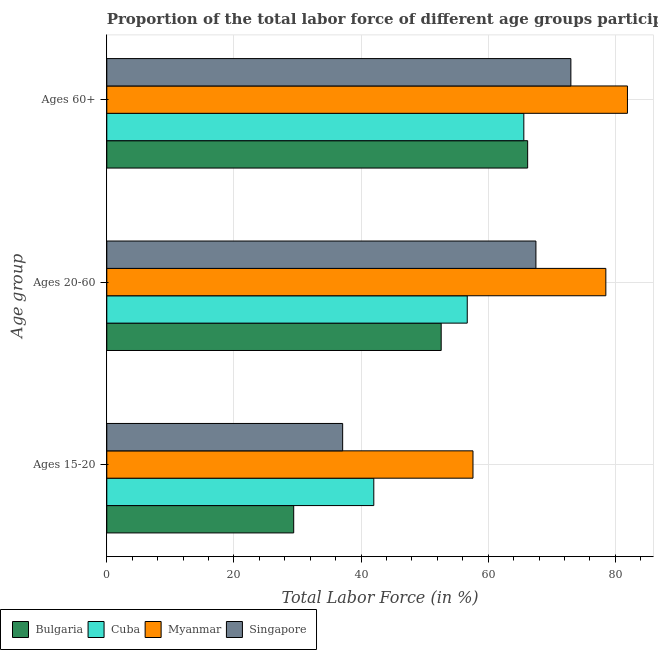Are the number of bars per tick equal to the number of legend labels?
Make the answer very short. Yes. Are the number of bars on each tick of the Y-axis equal?
Offer a terse response. Yes. How many bars are there on the 2nd tick from the bottom?
Provide a short and direct response. 4. What is the label of the 3rd group of bars from the top?
Keep it short and to the point. Ages 15-20. What is the percentage of labor force within the age group 20-60 in Singapore?
Offer a very short reply. 67.5. Across all countries, what is the maximum percentage of labor force within the age group 20-60?
Provide a short and direct response. 78.5. Across all countries, what is the minimum percentage of labor force within the age group 20-60?
Your response must be concise. 52.6. In which country was the percentage of labor force above age 60 maximum?
Your response must be concise. Myanmar. What is the total percentage of labor force within the age group 20-60 in the graph?
Keep it short and to the point. 255.3. What is the difference between the percentage of labor force above age 60 in Bulgaria and that in Singapore?
Offer a terse response. -6.8. What is the difference between the percentage of labor force within the age group 20-60 in Cuba and the percentage of labor force above age 60 in Bulgaria?
Keep it short and to the point. -9.5. What is the average percentage of labor force within the age group 20-60 per country?
Your response must be concise. 63.82. What is the difference between the percentage of labor force above age 60 and percentage of labor force within the age group 15-20 in Bulgaria?
Your answer should be compact. 36.8. In how many countries, is the percentage of labor force within the age group 20-60 greater than 52 %?
Provide a succinct answer. 4. What is the ratio of the percentage of labor force above age 60 in Cuba to that in Singapore?
Ensure brevity in your answer.  0.9. Is the percentage of labor force within the age group 20-60 in Myanmar less than that in Singapore?
Provide a short and direct response. No. What is the difference between the highest and the second highest percentage of labor force within the age group 15-20?
Keep it short and to the point. 15.6. What is the difference between the highest and the lowest percentage of labor force within the age group 15-20?
Keep it short and to the point. 28.2. In how many countries, is the percentage of labor force within the age group 15-20 greater than the average percentage of labor force within the age group 15-20 taken over all countries?
Offer a very short reply. 2. What does the 3rd bar from the top in Ages 20-60 represents?
Ensure brevity in your answer.  Cuba. How many bars are there?
Offer a terse response. 12. Are all the bars in the graph horizontal?
Your answer should be very brief. Yes. What is the difference between two consecutive major ticks on the X-axis?
Keep it short and to the point. 20. Are the values on the major ticks of X-axis written in scientific E-notation?
Your answer should be very brief. No. Does the graph contain any zero values?
Your answer should be compact. No. How are the legend labels stacked?
Provide a short and direct response. Horizontal. What is the title of the graph?
Offer a very short reply. Proportion of the total labor force of different age groups participating in production in 2011. What is the label or title of the Y-axis?
Ensure brevity in your answer.  Age group. What is the Total Labor Force (in %) in Bulgaria in Ages 15-20?
Provide a short and direct response. 29.4. What is the Total Labor Force (in %) in Myanmar in Ages 15-20?
Ensure brevity in your answer.  57.6. What is the Total Labor Force (in %) in Singapore in Ages 15-20?
Your answer should be compact. 37.1. What is the Total Labor Force (in %) in Bulgaria in Ages 20-60?
Your answer should be compact. 52.6. What is the Total Labor Force (in %) in Cuba in Ages 20-60?
Offer a terse response. 56.7. What is the Total Labor Force (in %) of Myanmar in Ages 20-60?
Your answer should be compact. 78.5. What is the Total Labor Force (in %) in Singapore in Ages 20-60?
Offer a terse response. 67.5. What is the Total Labor Force (in %) in Bulgaria in Ages 60+?
Your answer should be very brief. 66.2. What is the Total Labor Force (in %) in Cuba in Ages 60+?
Provide a short and direct response. 65.6. What is the Total Labor Force (in %) in Myanmar in Ages 60+?
Ensure brevity in your answer.  81.9. What is the Total Labor Force (in %) in Singapore in Ages 60+?
Provide a succinct answer. 73. Across all Age group, what is the maximum Total Labor Force (in %) in Bulgaria?
Ensure brevity in your answer.  66.2. Across all Age group, what is the maximum Total Labor Force (in %) in Cuba?
Your answer should be very brief. 65.6. Across all Age group, what is the maximum Total Labor Force (in %) in Myanmar?
Offer a terse response. 81.9. Across all Age group, what is the minimum Total Labor Force (in %) of Bulgaria?
Offer a terse response. 29.4. Across all Age group, what is the minimum Total Labor Force (in %) in Myanmar?
Your answer should be very brief. 57.6. Across all Age group, what is the minimum Total Labor Force (in %) in Singapore?
Offer a very short reply. 37.1. What is the total Total Labor Force (in %) in Bulgaria in the graph?
Your answer should be compact. 148.2. What is the total Total Labor Force (in %) of Cuba in the graph?
Your answer should be very brief. 164.3. What is the total Total Labor Force (in %) of Myanmar in the graph?
Your answer should be compact. 218. What is the total Total Labor Force (in %) of Singapore in the graph?
Your answer should be very brief. 177.6. What is the difference between the Total Labor Force (in %) in Bulgaria in Ages 15-20 and that in Ages 20-60?
Offer a terse response. -23.2. What is the difference between the Total Labor Force (in %) of Cuba in Ages 15-20 and that in Ages 20-60?
Your answer should be compact. -14.7. What is the difference between the Total Labor Force (in %) in Myanmar in Ages 15-20 and that in Ages 20-60?
Give a very brief answer. -20.9. What is the difference between the Total Labor Force (in %) in Singapore in Ages 15-20 and that in Ages 20-60?
Your answer should be compact. -30.4. What is the difference between the Total Labor Force (in %) of Bulgaria in Ages 15-20 and that in Ages 60+?
Your answer should be very brief. -36.8. What is the difference between the Total Labor Force (in %) in Cuba in Ages 15-20 and that in Ages 60+?
Keep it short and to the point. -23.6. What is the difference between the Total Labor Force (in %) in Myanmar in Ages 15-20 and that in Ages 60+?
Give a very brief answer. -24.3. What is the difference between the Total Labor Force (in %) of Singapore in Ages 15-20 and that in Ages 60+?
Make the answer very short. -35.9. What is the difference between the Total Labor Force (in %) in Cuba in Ages 20-60 and that in Ages 60+?
Give a very brief answer. -8.9. What is the difference between the Total Labor Force (in %) of Bulgaria in Ages 15-20 and the Total Labor Force (in %) of Cuba in Ages 20-60?
Your answer should be compact. -27.3. What is the difference between the Total Labor Force (in %) of Bulgaria in Ages 15-20 and the Total Labor Force (in %) of Myanmar in Ages 20-60?
Ensure brevity in your answer.  -49.1. What is the difference between the Total Labor Force (in %) in Bulgaria in Ages 15-20 and the Total Labor Force (in %) in Singapore in Ages 20-60?
Provide a succinct answer. -38.1. What is the difference between the Total Labor Force (in %) in Cuba in Ages 15-20 and the Total Labor Force (in %) in Myanmar in Ages 20-60?
Your answer should be compact. -36.5. What is the difference between the Total Labor Force (in %) of Cuba in Ages 15-20 and the Total Labor Force (in %) of Singapore in Ages 20-60?
Provide a succinct answer. -25.5. What is the difference between the Total Labor Force (in %) in Bulgaria in Ages 15-20 and the Total Labor Force (in %) in Cuba in Ages 60+?
Provide a succinct answer. -36.2. What is the difference between the Total Labor Force (in %) in Bulgaria in Ages 15-20 and the Total Labor Force (in %) in Myanmar in Ages 60+?
Your answer should be compact. -52.5. What is the difference between the Total Labor Force (in %) in Bulgaria in Ages 15-20 and the Total Labor Force (in %) in Singapore in Ages 60+?
Give a very brief answer. -43.6. What is the difference between the Total Labor Force (in %) of Cuba in Ages 15-20 and the Total Labor Force (in %) of Myanmar in Ages 60+?
Keep it short and to the point. -39.9. What is the difference between the Total Labor Force (in %) of Cuba in Ages 15-20 and the Total Labor Force (in %) of Singapore in Ages 60+?
Your answer should be compact. -31. What is the difference between the Total Labor Force (in %) in Myanmar in Ages 15-20 and the Total Labor Force (in %) in Singapore in Ages 60+?
Your answer should be very brief. -15.4. What is the difference between the Total Labor Force (in %) in Bulgaria in Ages 20-60 and the Total Labor Force (in %) in Cuba in Ages 60+?
Make the answer very short. -13. What is the difference between the Total Labor Force (in %) in Bulgaria in Ages 20-60 and the Total Labor Force (in %) in Myanmar in Ages 60+?
Provide a short and direct response. -29.3. What is the difference between the Total Labor Force (in %) of Bulgaria in Ages 20-60 and the Total Labor Force (in %) of Singapore in Ages 60+?
Your answer should be very brief. -20.4. What is the difference between the Total Labor Force (in %) in Cuba in Ages 20-60 and the Total Labor Force (in %) in Myanmar in Ages 60+?
Ensure brevity in your answer.  -25.2. What is the difference between the Total Labor Force (in %) in Cuba in Ages 20-60 and the Total Labor Force (in %) in Singapore in Ages 60+?
Ensure brevity in your answer.  -16.3. What is the average Total Labor Force (in %) in Bulgaria per Age group?
Ensure brevity in your answer.  49.4. What is the average Total Labor Force (in %) in Cuba per Age group?
Ensure brevity in your answer.  54.77. What is the average Total Labor Force (in %) in Myanmar per Age group?
Your answer should be very brief. 72.67. What is the average Total Labor Force (in %) in Singapore per Age group?
Offer a very short reply. 59.2. What is the difference between the Total Labor Force (in %) in Bulgaria and Total Labor Force (in %) in Cuba in Ages 15-20?
Provide a succinct answer. -12.6. What is the difference between the Total Labor Force (in %) in Bulgaria and Total Labor Force (in %) in Myanmar in Ages 15-20?
Provide a succinct answer. -28.2. What is the difference between the Total Labor Force (in %) in Bulgaria and Total Labor Force (in %) in Singapore in Ages 15-20?
Your response must be concise. -7.7. What is the difference between the Total Labor Force (in %) in Cuba and Total Labor Force (in %) in Myanmar in Ages 15-20?
Give a very brief answer. -15.6. What is the difference between the Total Labor Force (in %) of Cuba and Total Labor Force (in %) of Singapore in Ages 15-20?
Ensure brevity in your answer.  4.9. What is the difference between the Total Labor Force (in %) of Bulgaria and Total Labor Force (in %) of Myanmar in Ages 20-60?
Your response must be concise. -25.9. What is the difference between the Total Labor Force (in %) of Bulgaria and Total Labor Force (in %) of Singapore in Ages 20-60?
Keep it short and to the point. -14.9. What is the difference between the Total Labor Force (in %) in Cuba and Total Labor Force (in %) in Myanmar in Ages 20-60?
Ensure brevity in your answer.  -21.8. What is the difference between the Total Labor Force (in %) in Cuba and Total Labor Force (in %) in Singapore in Ages 20-60?
Offer a very short reply. -10.8. What is the difference between the Total Labor Force (in %) in Bulgaria and Total Labor Force (in %) in Myanmar in Ages 60+?
Ensure brevity in your answer.  -15.7. What is the difference between the Total Labor Force (in %) of Bulgaria and Total Labor Force (in %) of Singapore in Ages 60+?
Keep it short and to the point. -6.8. What is the difference between the Total Labor Force (in %) of Cuba and Total Labor Force (in %) of Myanmar in Ages 60+?
Your answer should be very brief. -16.3. What is the difference between the Total Labor Force (in %) of Cuba and Total Labor Force (in %) of Singapore in Ages 60+?
Your response must be concise. -7.4. What is the ratio of the Total Labor Force (in %) in Bulgaria in Ages 15-20 to that in Ages 20-60?
Offer a terse response. 0.56. What is the ratio of the Total Labor Force (in %) of Cuba in Ages 15-20 to that in Ages 20-60?
Offer a very short reply. 0.74. What is the ratio of the Total Labor Force (in %) of Myanmar in Ages 15-20 to that in Ages 20-60?
Offer a very short reply. 0.73. What is the ratio of the Total Labor Force (in %) in Singapore in Ages 15-20 to that in Ages 20-60?
Ensure brevity in your answer.  0.55. What is the ratio of the Total Labor Force (in %) of Bulgaria in Ages 15-20 to that in Ages 60+?
Provide a short and direct response. 0.44. What is the ratio of the Total Labor Force (in %) in Cuba in Ages 15-20 to that in Ages 60+?
Keep it short and to the point. 0.64. What is the ratio of the Total Labor Force (in %) in Myanmar in Ages 15-20 to that in Ages 60+?
Offer a very short reply. 0.7. What is the ratio of the Total Labor Force (in %) of Singapore in Ages 15-20 to that in Ages 60+?
Keep it short and to the point. 0.51. What is the ratio of the Total Labor Force (in %) in Bulgaria in Ages 20-60 to that in Ages 60+?
Your response must be concise. 0.79. What is the ratio of the Total Labor Force (in %) in Cuba in Ages 20-60 to that in Ages 60+?
Provide a succinct answer. 0.86. What is the ratio of the Total Labor Force (in %) of Myanmar in Ages 20-60 to that in Ages 60+?
Provide a short and direct response. 0.96. What is the ratio of the Total Labor Force (in %) in Singapore in Ages 20-60 to that in Ages 60+?
Your answer should be compact. 0.92. What is the difference between the highest and the lowest Total Labor Force (in %) of Bulgaria?
Your answer should be very brief. 36.8. What is the difference between the highest and the lowest Total Labor Force (in %) in Cuba?
Offer a very short reply. 23.6. What is the difference between the highest and the lowest Total Labor Force (in %) of Myanmar?
Offer a very short reply. 24.3. What is the difference between the highest and the lowest Total Labor Force (in %) of Singapore?
Give a very brief answer. 35.9. 